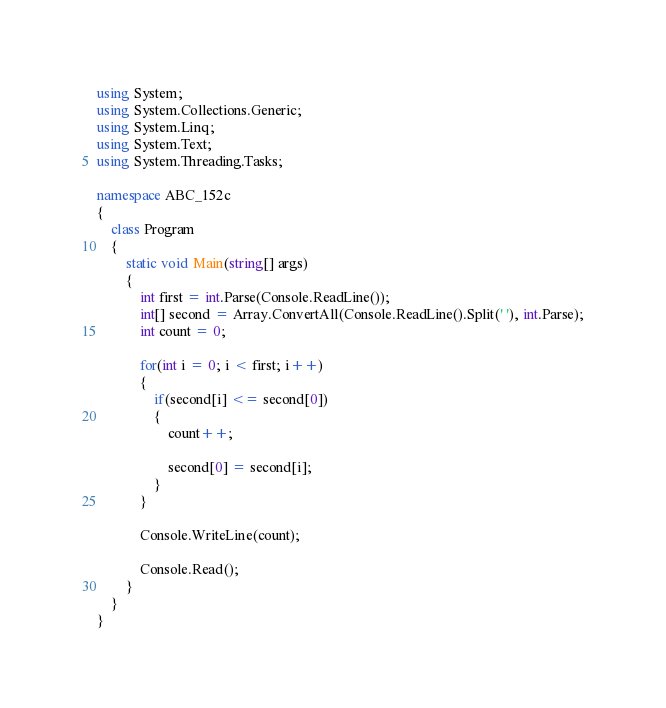Convert code to text. <code><loc_0><loc_0><loc_500><loc_500><_C#_>using System;
using System.Collections.Generic;
using System.Linq;
using System.Text;
using System.Threading.Tasks;

namespace ABC_152c
{
    class Program
    {
        static void Main(string[] args)
        {
            int first = int.Parse(Console.ReadLine());
            int[] second = Array.ConvertAll(Console.ReadLine().Split(' '), int.Parse);
            int count = 0;
            
            for(int i = 0; i < first; i++)
            {
                if(second[i] <= second[0])
                {
                    count++;

                    second[0] = second[i];
                }
            }

            Console.WriteLine(count);

            Console.Read();
        }
    }
}
</code> 